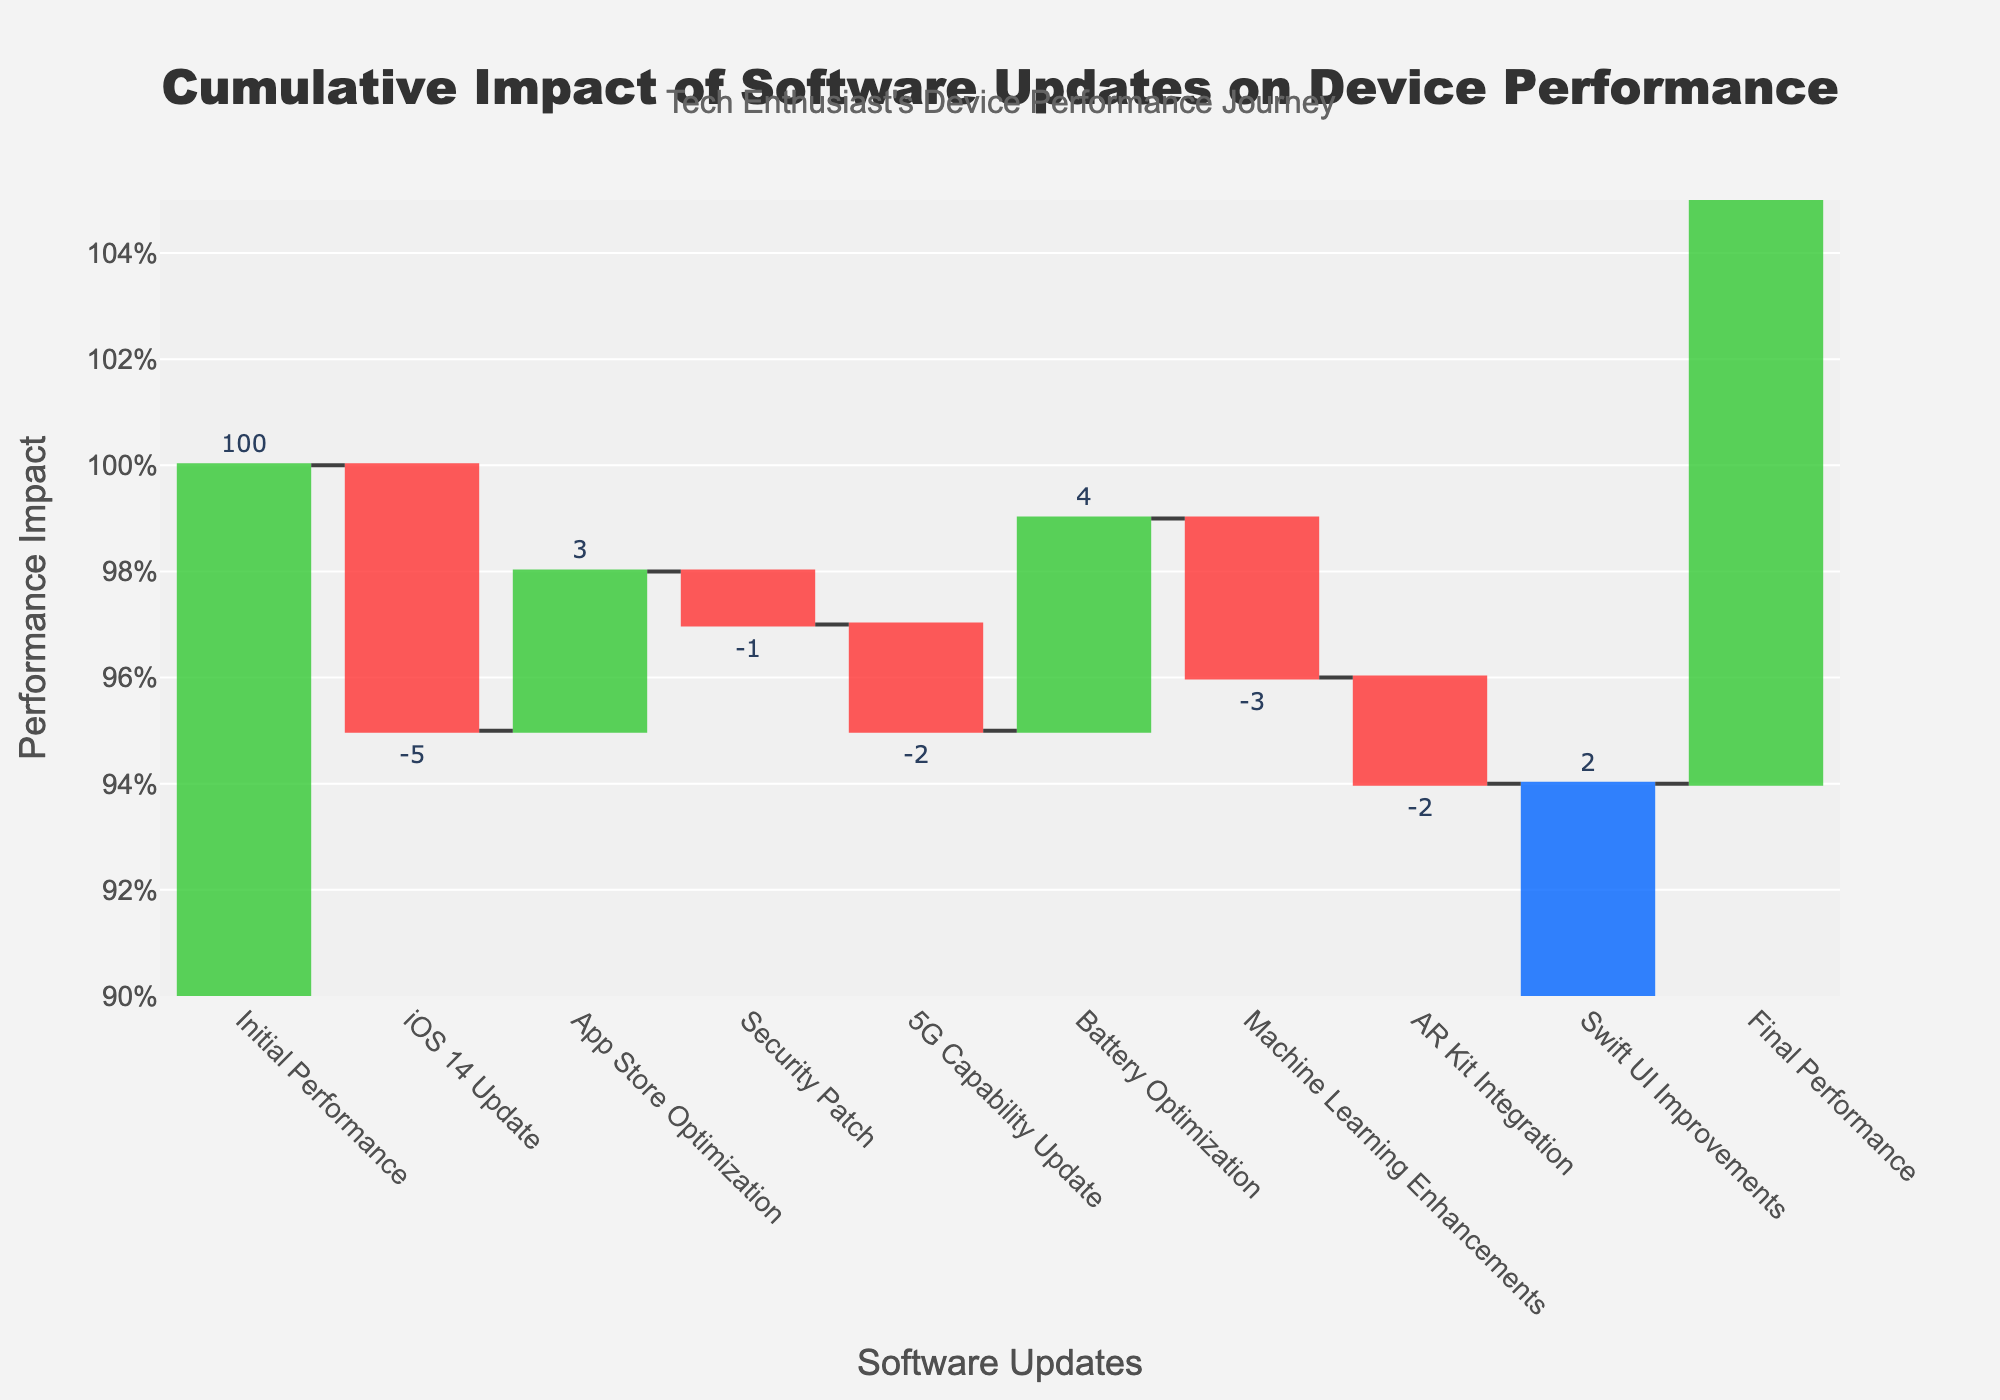What is the initial performance value? The initial performance value is explicitly mentioned in the first category of the chart, which is labeled "Initial Performance".
Answer: 100 What is the final performance value? The final performance value is explicitly mentioned in the last category of the chart, which is labeled "Final Performance".
Answer: 96 Which update has the most positive impact on device performance? By looking at the bars labeled with positive values, we can see that the "Battery Optimization" update has the highest positive value at 4.
Answer: Battery Optimization Which update has the most negative impact on device performance? By examining the bars labeled with negative values, we can identify that the "iOS 14 Update" has the largest negative impact with a value of -5.
Answer: iOS 14 Update What is the net impact of all updates combined on device performance? To find the net impact, we sum the values of all the updates. Calculating (-5 + 3 - 1 - 2 + 4 - 3 - 2 + 2) = -4.
Answer: -4 How does the "App Store Optimization" update compare to the "AR Kit Integration" update in terms of performance impact? The "App Store Optimization" update has a value of 3, while the "AR Kit Integration" update has a value of -2. The difference in their impacts is 3 - (-2) = 5.
Answer: App Store Optimization What is the cumulative performance after the "5G Capability Update"? Starting from 100, we subtract 5 for "iOS 14 Update", add 3 for "App Store Optimization", subtract 1 for "Security Patch", and subtract 2 for "5G Capability Update", resulting in 100 - 5 + 3 - 1 - 2 = 95.
Answer: 95 Are there more updates that positively impact performance or negatively impact it? We count the number of updates with positive values (App Store Optimization, Battery Optimization, Swift UI Improvements) which are 3, and updates with negative values (iOS 14 Update, Security Patch, 5G Capability Update, Machine Learning Enhancements, AR Kit Integration) which are 5.
Answer: More negative What is the average impact of all updates (excluding initial and final performance)? To find the average, sum the impact values of all updates (-5 + 3 - 1 - 2 + 4 - 3 - 2 + 2) = -4, then divide by the number of updates (8), resulting in -4 / 8 = -0.5.
Answer: -0.5 